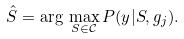<formula> <loc_0><loc_0><loc_500><loc_500>\hat { S } = \arg \, \max _ { S \in \mathcal { C } } P ( y | S , g _ { j } ) . \\</formula> 